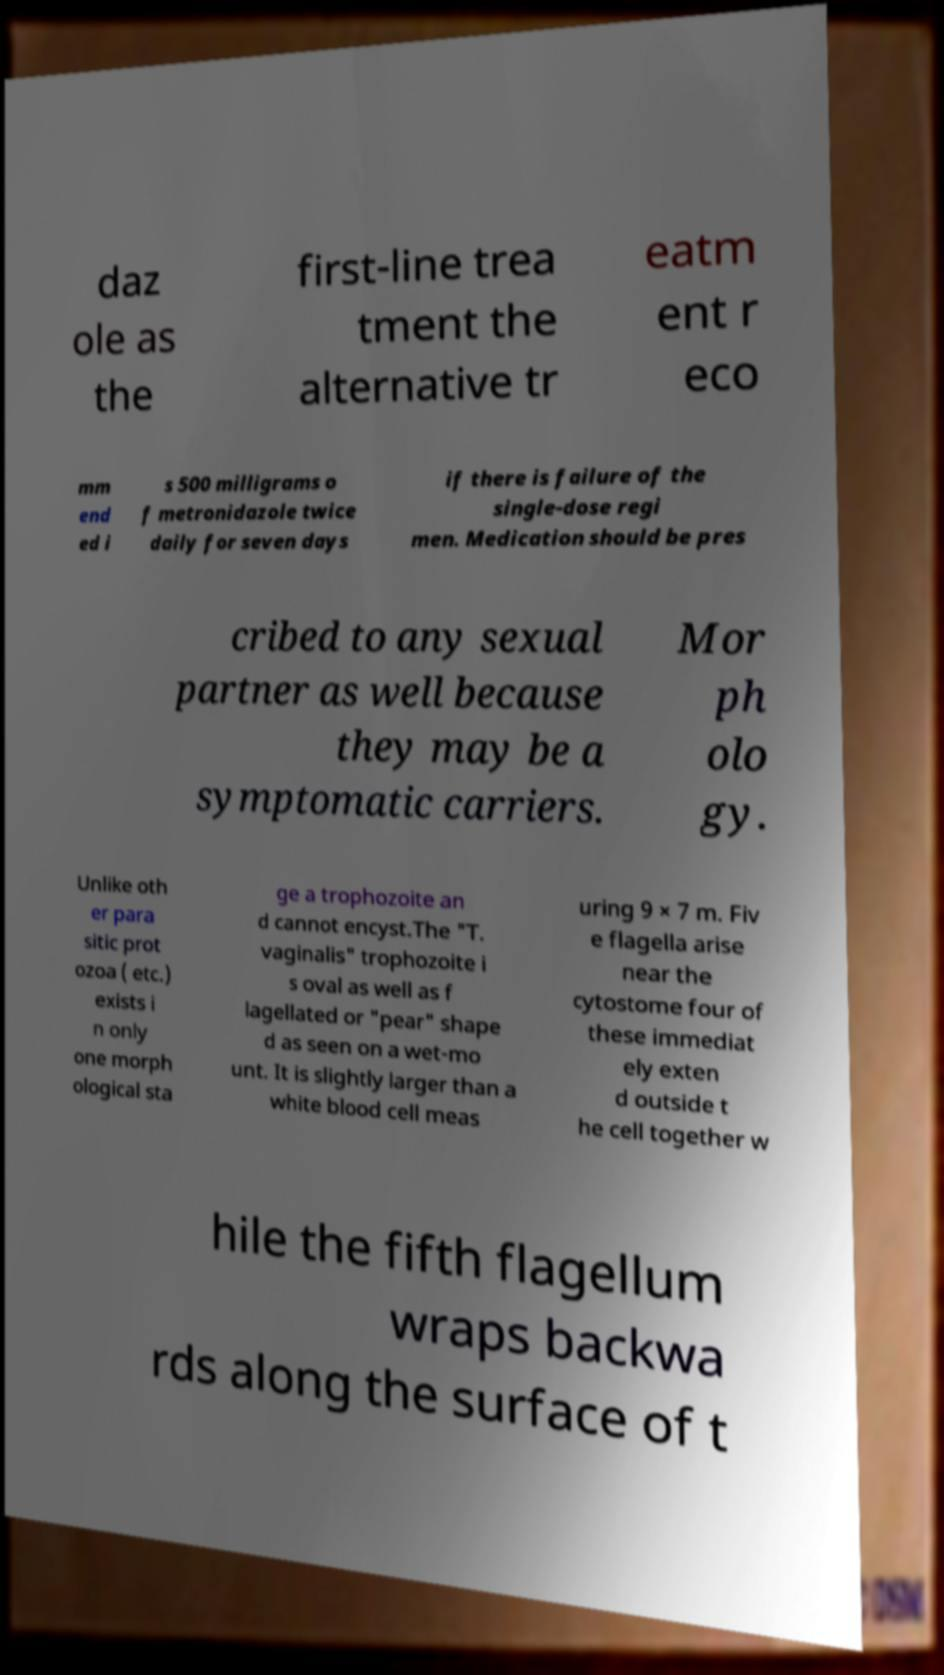Could you extract and type out the text from this image? daz ole as the first-line trea tment the alternative tr eatm ent r eco mm end ed i s 500 milligrams o f metronidazole twice daily for seven days if there is failure of the single-dose regi men. Medication should be pres cribed to any sexual partner as well because they may be a symptomatic carriers. Mor ph olo gy. Unlike oth er para sitic prot ozoa ( etc.) exists i n only one morph ological sta ge a trophozoite an d cannot encyst.The "T. vaginalis" trophozoite i s oval as well as f lagellated or "pear" shape d as seen on a wet-mo unt. It is slightly larger than a white blood cell meas uring 9 × 7 m. Fiv e flagella arise near the cytostome four of these immediat ely exten d outside t he cell together w hile the fifth flagellum wraps backwa rds along the surface of t 